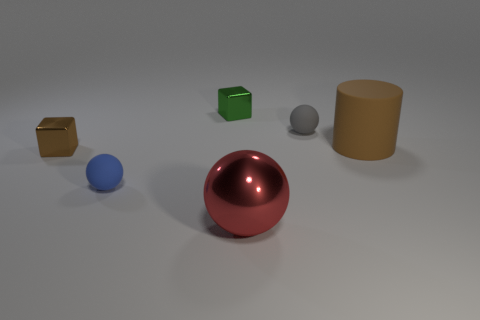Are there more tiny blue metal spheres than green metal objects?
Provide a short and direct response. No. There is a small matte thing in front of the rubber cylinder; is its color the same as the block that is in front of the large matte cylinder?
Provide a succinct answer. No. Is the material of the big thing left of the tiny gray ball the same as the sphere behind the big brown cylinder?
Offer a terse response. No. How many gray things are the same size as the green thing?
Give a very brief answer. 1. Is the number of large blue matte cylinders less than the number of tiny cubes?
Provide a short and direct response. Yes. What shape is the matte thing that is to the left of the shiny thing right of the small green object?
Your answer should be compact. Sphere. What is the shape of the gray thing that is the same size as the blue object?
Your answer should be very brief. Sphere. Are there any green objects of the same shape as the large red thing?
Offer a terse response. No. What is the material of the big brown cylinder?
Your answer should be very brief. Rubber. There is a large brown object; are there any small gray objects to the left of it?
Offer a terse response. Yes. 